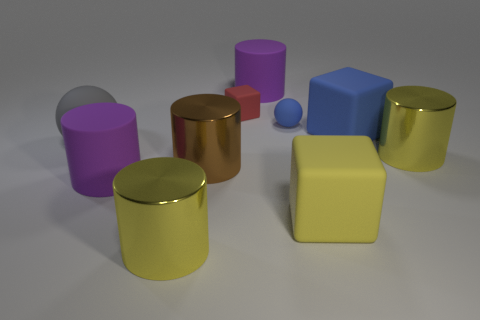Subtract all cyan cubes. How many yellow cylinders are left? 2 Subtract all big brown cylinders. How many cylinders are left? 4 Subtract 3 cylinders. How many cylinders are left? 2 Subtract all spheres. How many objects are left? 8 Subtract all blue spheres. How many spheres are left? 1 Add 7 tiny blue rubber balls. How many tiny blue rubber balls exist? 8 Subtract 0 green blocks. How many objects are left? 10 Subtract all yellow spheres. Subtract all brown cylinders. How many spheres are left? 2 Subtract all brown matte cylinders. Subtract all yellow cylinders. How many objects are left? 8 Add 9 big brown cylinders. How many big brown cylinders are left? 10 